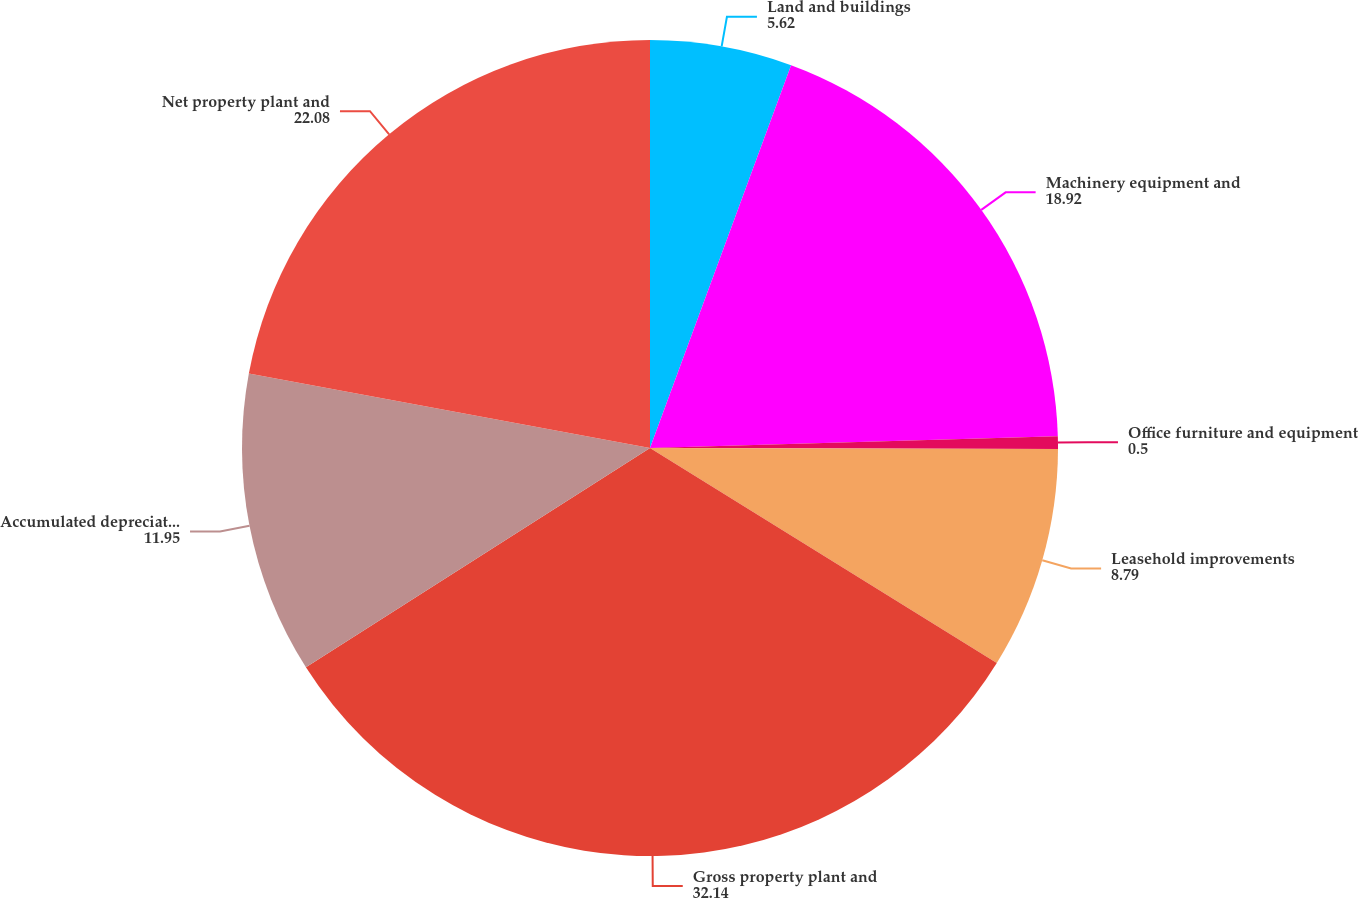Convert chart to OTSL. <chart><loc_0><loc_0><loc_500><loc_500><pie_chart><fcel>Land and buildings<fcel>Machinery equipment and<fcel>Office furniture and equipment<fcel>Leasehold improvements<fcel>Gross property plant and<fcel>Accumulated depreciation and<fcel>Net property plant and<nl><fcel>5.62%<fcel>18.92%<fcel>0.5%<fcel>8.79%<fcel>32.14%<fcel>11.95%<fcel>22.08%<nl></chart> 